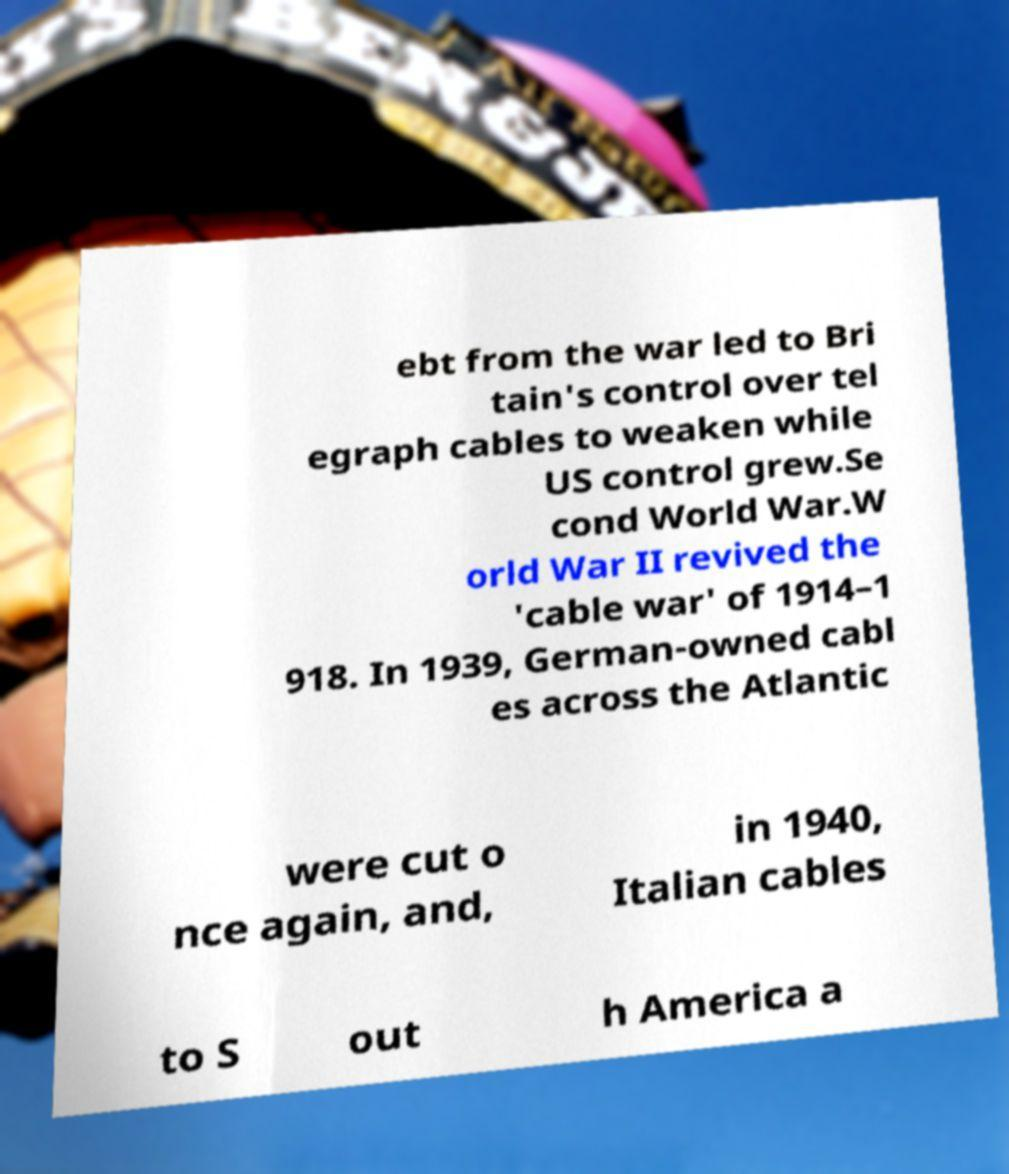I need the written content from this picture converted into text. Can you do that? ebt from the war led to Bri tain's control over tel egraph cables to weaken while US control grew.Se cond World War.W orld War II revived the 'cable war' of 1914–1 918. In 1939, German-owned cabl es across the Atlantic were cut o nce again, and, in 1940, Italian cables to S out h America a 